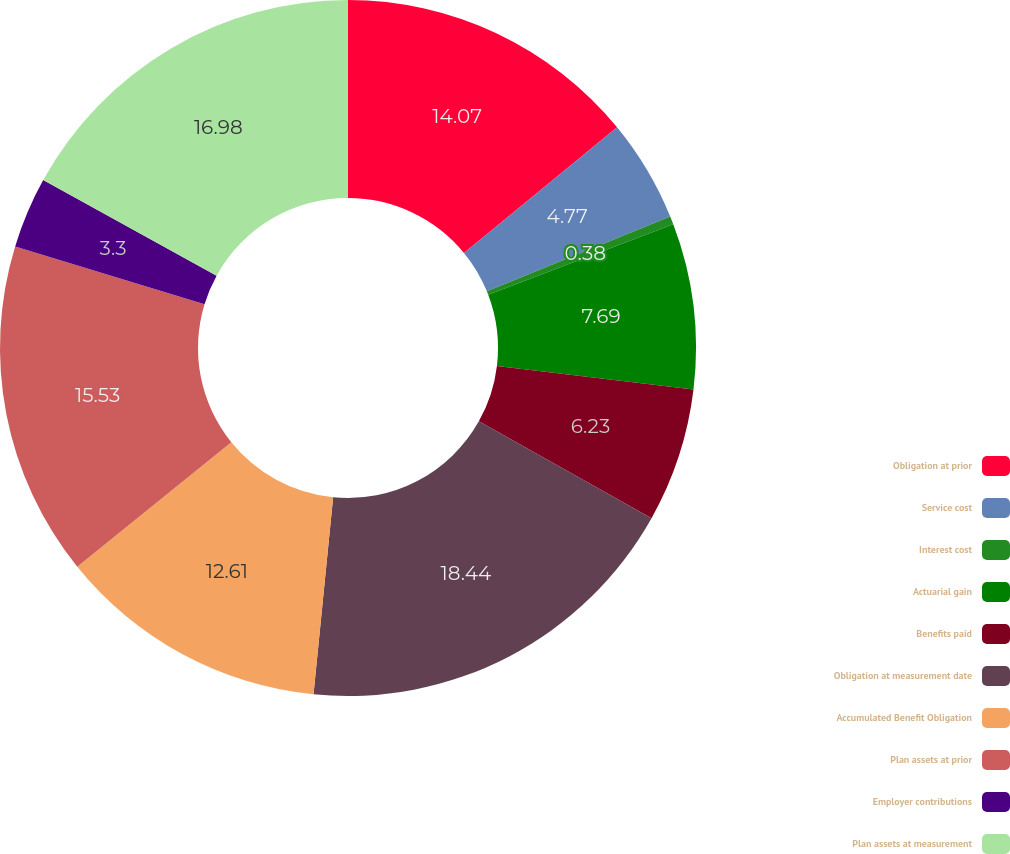Convert chart to OTSL. <chart><loc_0><loc_0><loc_500><loc_500><pie_chart><fcel>Obligation at prior<fcel>Service cost<fcel>Interest cost<fcel>Actuarial gain<fcel>Benefits paid<fcel>Obligation at measurement date<fcel>Accumulated Benefit Obligation<fcel>Plan assets at prior<fcel>Employer contributions<fcel>Plan assets at measurement<nl><fcel>14.07%<fcel>4.77%<fcel>0.38%<fcel>7.69%<fcel>6.23%<fcel>18.45%<fcel>12.61%<fcel>15.53%<fcel>3.3%<fcel>16.99%<nl></chart> 